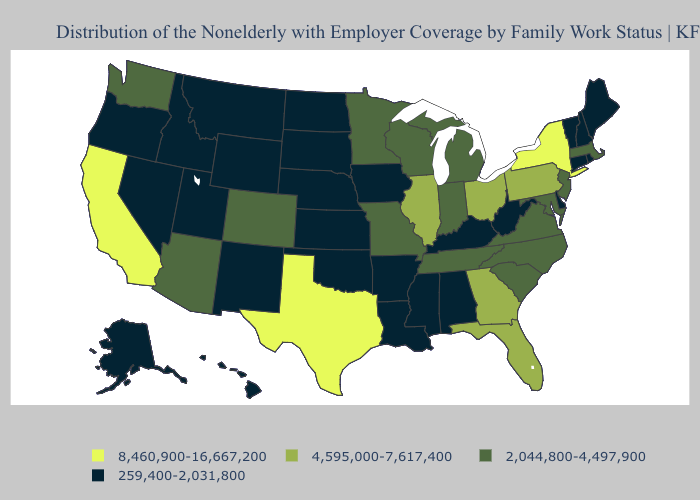What is the value of Tennessee?
Keep it brief. 2,044,800-4,497,900. Which states have the lowest value in the South?
Concise answer only. Alabama, Arkansas, Delaware, Kentucky, Louisiana, Mississippi, Oklahoma, West Virginia. What is the value of Tennessee?
Concise answer only. 2,044,800-4,497,900. Does West Virginia have a lower value than Wisconsin?
Quick response, please. Yes. Name the states that have a value in the range 259,400-2,031,800?
Short answer required. Alabama, Alaska, Arkansas, Connecticut, Delaware, Hawaii, Idaho, Iowa, Kansas, Kentucky, Louisiana, Maine, Mississippi, Montana, Nebraska, Nevada, New Hampshire, New Mexico, North Dakota, Oklahoma, Oregon, Rhode Island, South Dakota, Utah, Vermont, West Virginia, Wyoming. Name the states that have a value in the range 8,460,900-16,667,200?
Short answer required. California, New York, Texas. Name the states that have a value in the range 4,595,000-7,617,400?
Give a very brief answer. Florida, Georgia, Illinois, Ohio, Pennsylvania. What is the highest value in the USA?
Write a very short answer. 8,460,900-16,667,200. Does the first symbol in the legend represent the smallest category?
Concise answer only. No. Which states have the lowest value in the USA?
Short answer required. Alabama, Alaska, Arkansas, Connecticut, Delaware, Hawaii, Idaho, Iowa, Kansas, Kentucky, Louisiana, Maine, Mississippi, Montana, Nebraska, Nevada, New Hampshire, New Mexico, North Dakota, Oklahoma, Oregon, Rhode Island, South Dakota, Utah, Vermont, West Virginia, Wyoming. What is the value of Oregon?
Keep it brief. 259,400-2,031,800. Among the states that border Minnesota , does Iowa have the highest value?
Short answer required. No. Among the states that border Louisiana , which have the highest value?
Write a very short answer. Texas. What is the highest value in states that border Maine?
Short answer required. 259,400-2,031,800. Does the map have missing data?
Answer briefly. No. 